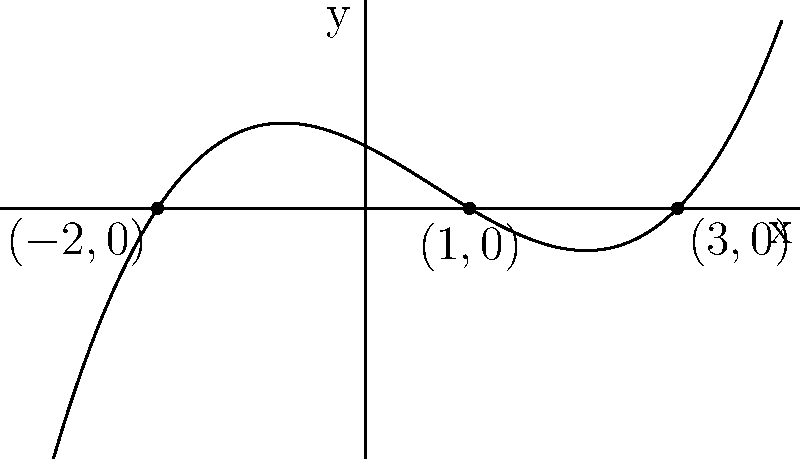Sketch the graph of a polynomial function with roots at $x=-2$, $x=1$, and $x=3$. The function should have a positive leading coefficient and degree 3. Label the roots on your sketch. To sketch this polynomial graph, we'll follow these steps:

1) Identify the roots: The roots are at $x=-2$, $x=1$, and $x=3$.

2) Determine the degree: The polynomial has 3 roots, so it's of degree 3.

3) Consider the leading coefficient: It's positive, so the end behavior will be upward on both sides.

4) Sketch the basic shape:
   - Plot the roots on the x-axis.
   - The graph will cross the x-axis at these points.
   - Since the degree is odd (3) and the leading coefficient is positive, the graph will start in the third quadrant and end in the first quadrant.

5) Determine the behavior between roots:
   - Between $x=-2$ and $x=1$, the graph will be above the x-axis.
   - Between $x=1$ and $x=3$, the graph will be below the x-axis.

6) Sketch the final curve:
   - Start below the x-axis to the left of $x=-2$.
   - Cross the x-axis at $x=-2$ going upward.
   - Reach a local maximum between $x=-2$ and $x=1$.
   - Cross the x-axis at $x=1$ going downward.
   - Reach a local minimum between $x=1$ and $x=3$.
   - Cross the x-axis at $x=3$ going upward.
   - Continue upward to the right of $x=3$.

7) Label the roots on the sketch as $(-2,0)$, $(1,0)$, and $(3,0)$.

This process results in a sketch similar to the one provided in the graph above.
Answer: A cubic curve crossing x-axis at $(-2,0)$, $(1,0)$, and $(3,0)$, starting in third quadrant and ending in first quadrant. 